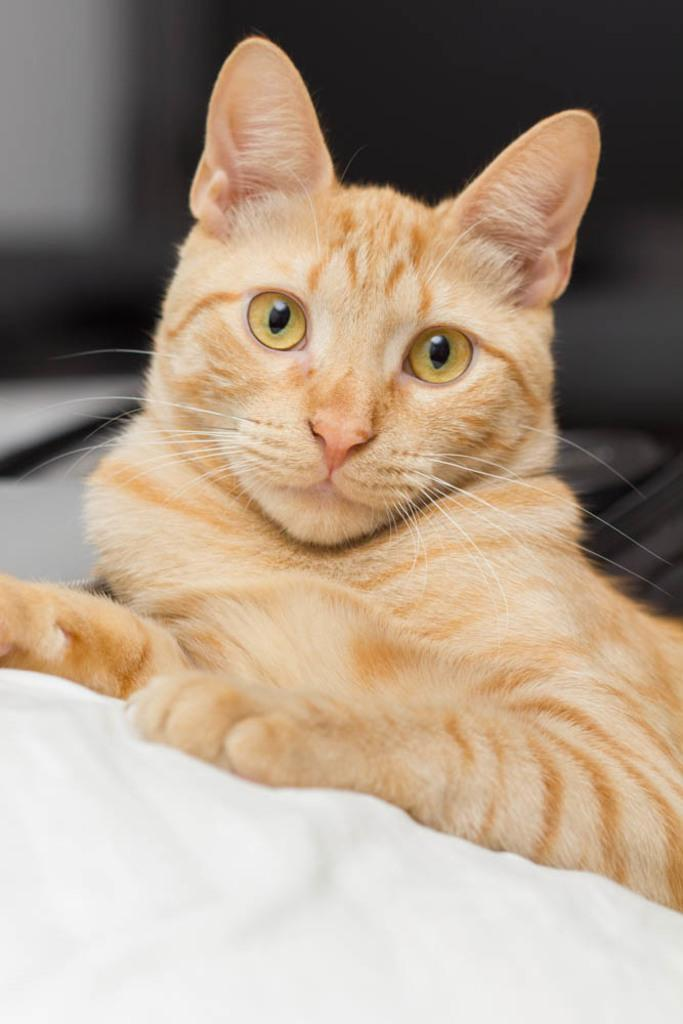What type of animal is in the image? There is a cat in the image. What is the cat sitting or lying on? The cat is on a cloth. Where is the cat and the cloth located in the image? The cat and the cloth are in the center of the image. Can you see any caves in the image? There are no caves present in the image. Is the cat playing baseball in the image? There is no indication of the cat playing baseball or any other sport in the image. 